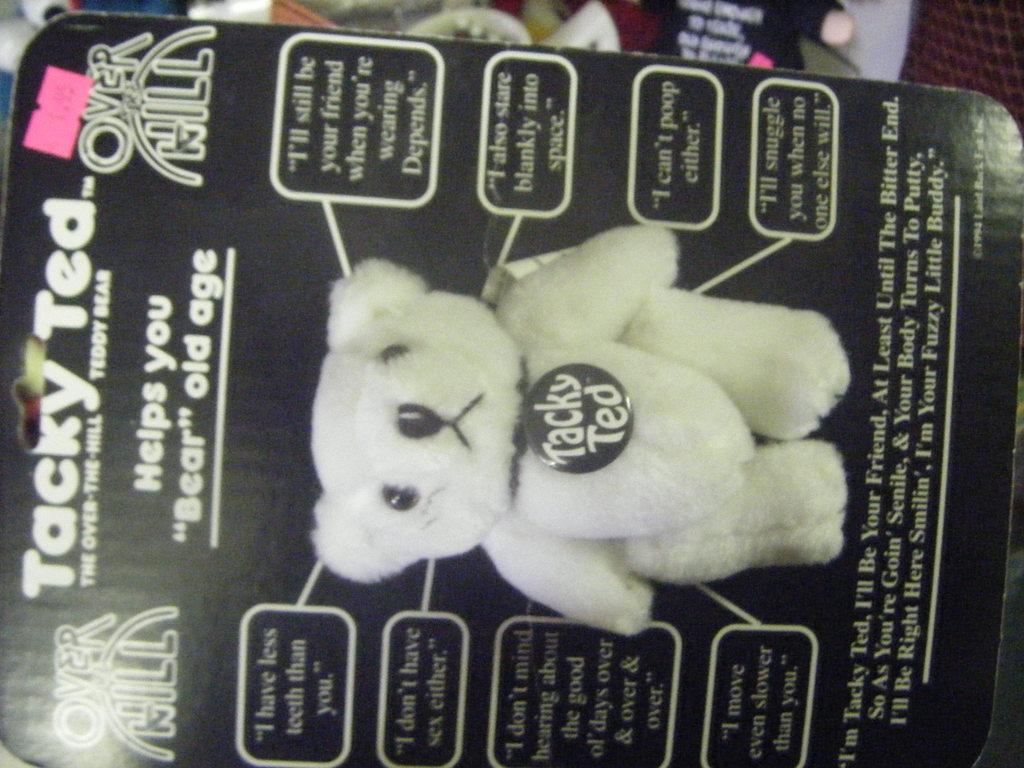In one or two sentences, can you explain what this image depicts? In the picture I can see the teddy bear packaging box. I can see the teddy bear photo and text on the packaging box. 